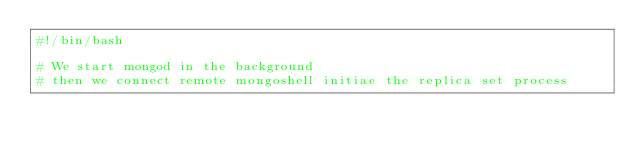<code> <loc_0><loc_0><loc_500><loc_500><_Bash_>#!/bin/bash

# We start mongod in the background
# then we connect remote mongoshell initiae the replica set process</code> 